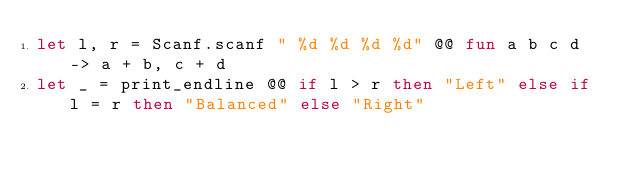<code> <loc_0><loc_0><loc_500><loc_500><_OCaml_>let l, r = Scanf.scanf " %d %d %d %d" @@ fun a b c d -> a + b, c + d
let _ = print_endline @@ if l > r then "Left" else if l = r then "Balanced" else "Right"</code> 